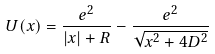Convert formula to latex. <formula><loc_0><loc_0><loc_500><loc_500>U ( x ) = \frac { e ^ { 2 } } { | x | + R } - \frac { e ^ { 2 } } { \sqrt { x ^ { 2 } + 4 D ^ { 2 } } }</formula> 